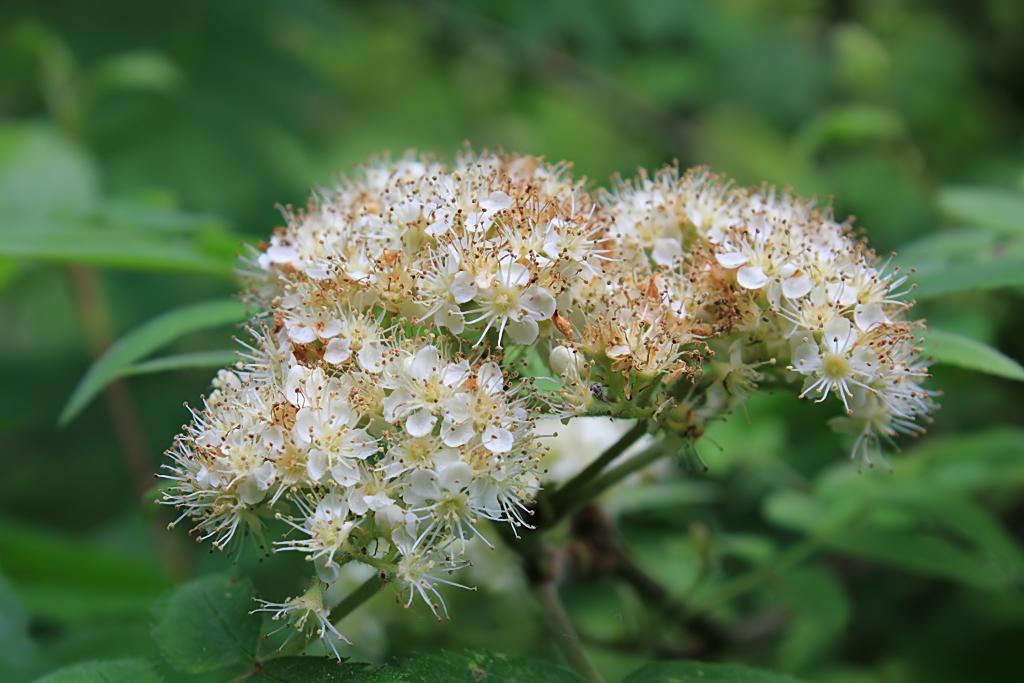Please provide a concise description of this image. In this image, we can see flowers on the blur background. 